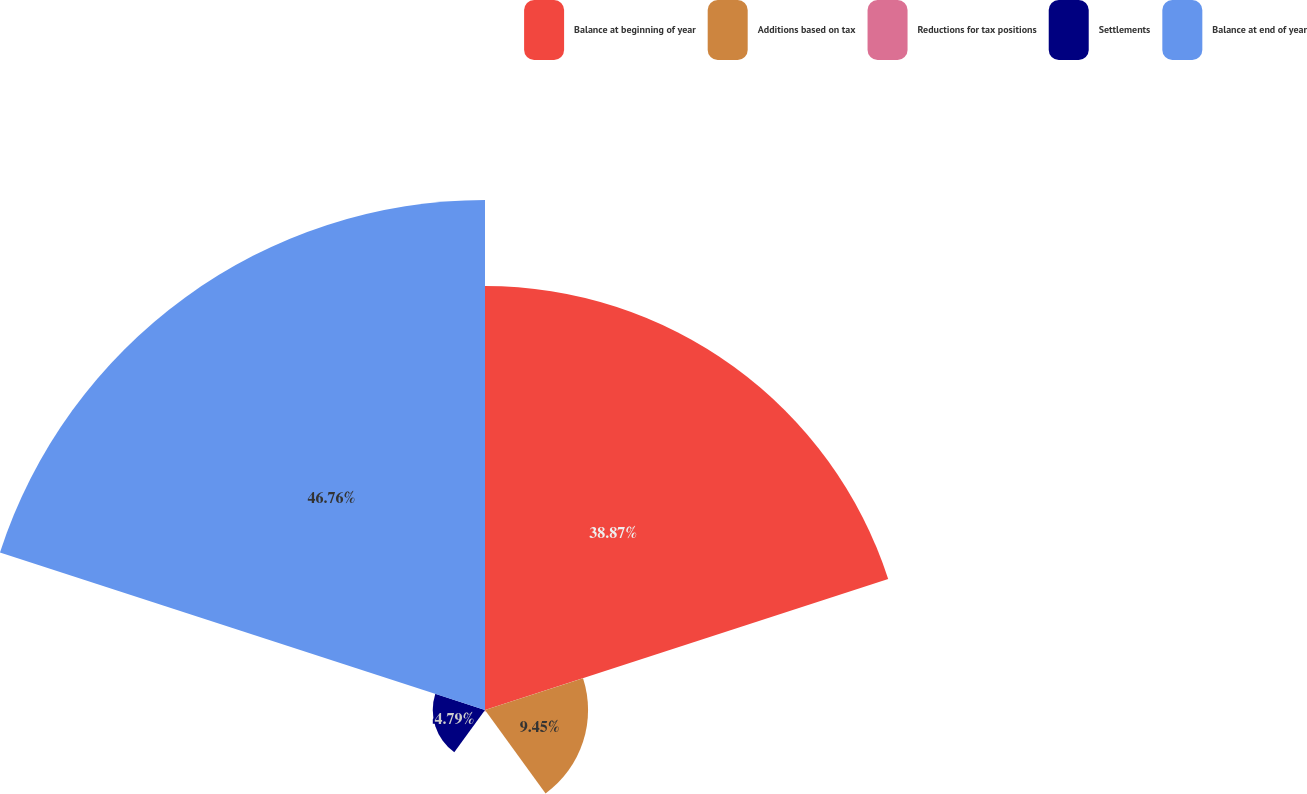Convert chart to OTSL. <chart><loc_0><loc_0><loc_500><loc_500><pie_chart><fcel>Balance at beginning of year<fcel>Additions based on tax<fcel>Reductions for tax positions<fcel>Settlements<fcel>Balance at end of year<nl><fcel>38.87%<fcel>9.45%<fcel>0.13%<fcel>4.79%<fcel>46.76%<nl></chart> 